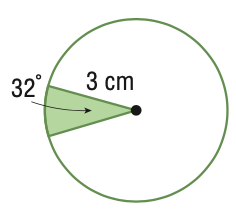Question: Find the area of the sector. Round to the nearest tenth.
Choices:
A. 1.7
B. 2.5
C. 25.8
D. 28.3
Answer with the letter. Answer: B 